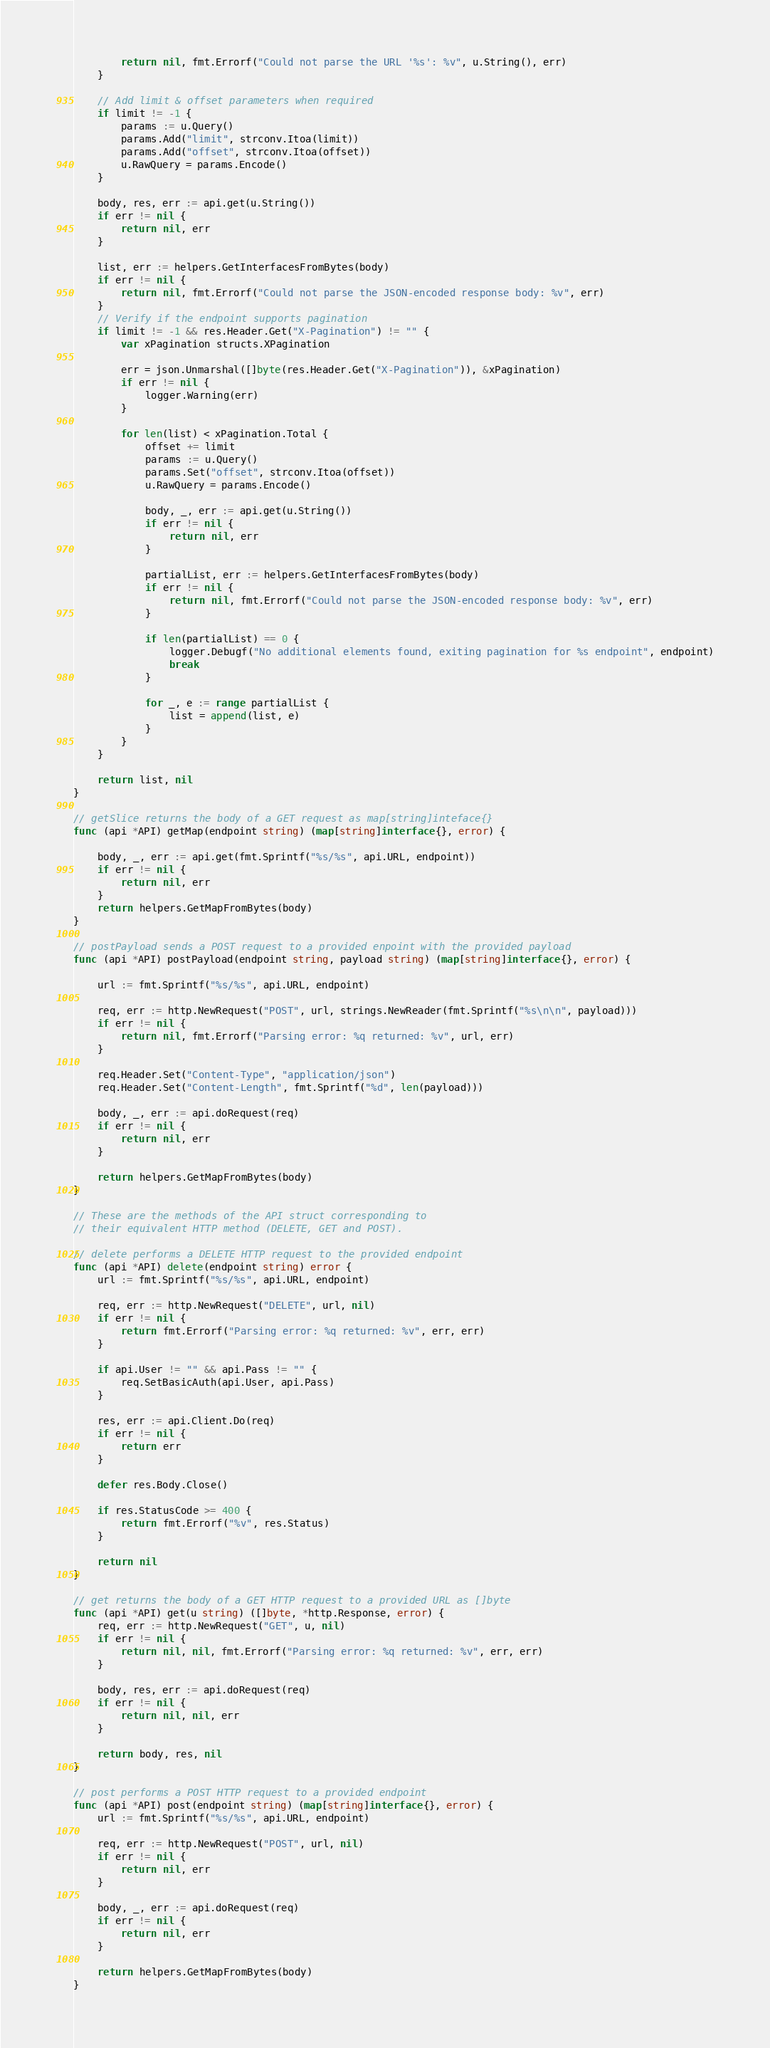Convert code to text. <code><loc_0><loc_0><loc_500><loc_500><_Go_>		return nil, fmt.Errorf("Could not parse the URL '%s': %v", u.String(), err)
	}

	// Add limit & offset parameters when required
	if limit != -1 {
		params := u.Query()
		params.Add("limit", strconv.Itoa(limit))
		params.Add("offset", strconv.Itoa(offset))
		u.RawQuery = params.Encode()
	}

	body, res, err := api.get(u.String())
	if err != nil {
		return nil, err
	}

	list, err := helpers.GetInterfacesFromBytes(body)
	if err != nil {
		return nil, fmt.Errorf("Could not parse the JSON-encoded response body: %v", err)
	}
	// Verify if the endpoint supports pagination
	if limit != -1 && res.Header.Get("X-Pagination") != "" {
		var xPagination structs.XPagination

		err = json.Unmarshal([]byte(res.Header.Get("X-Pagination")), &xPagination)
		if err != nil {
			logger.Warning(err)
		}

		for len(list) < xPagination.Total {
			offset += limit
			params := u.Query()
			params.Set("offset", strconv.Itoa(offset))
			u.RawQuery = params.Encode()

			body, _, err := api.get(u.String())
			if err != nil {
				return nil, err
			}

			partialList, err := helpers.GetInterfacesFromBytes(body)
			if err != nil {
				return nil, fmt.Errorf("Could not parse the JSON-encoded response body: %v", err)
			}

			if len(partialList) == 0 {
				logger.Debugf("No additional elements found, exiting pagination for %s endpoint", endpoint)
				break
			}

			for _, e := range partialList {
				list = append(list, e)
			}
		}
	}

	return list, nil
}

// getSlice returns the body of a GET request as map[string]inteface{}
func (api *API) getMap(endpoint string) (map[string]interface{}, error) {

	body, _, err := api.get(fmt.Sprintf("%s/%s", api.URL, endpoint))
	if err != nil {
		return nil, err
	}
	return helpers.GetMapFromBytes(body)
}

// postPayload sends a POST request to a provided enpoint with the provided payload
func (api *API) postPayload(endpoint string, payload string) (map[string]interface{}, error) {

	url := fmt.Sprintf("%s/%s", api.URL, endpoint)

	req, err := http.NewRequest("POST", url, strings.NewReader(fmt.Sprintf("%s\n\n", payload)))
	if err != nil {
		return nil, fmt.Errorf("Parsing error: %q returned: %v", url, err)
	}

	req.Header.Set("Content-Type", "application/json")
	req.Header.Set("Content-Length", fmt.Sprintf("%d", len(payload)))

	body, _, err := api.doRequest(req)
	if err != nil {
		return nil, err
	}

	return helpers.GetMapFromBytes(body)
}

// These are the methods of the API struct corresponding to
// their equivalent HTTP method (DELETE, GET and POST).

// delete performs a DELETE HTTP request to the provided endpoint
func (api *API) delete(endpoint string) error {
	url := fmt.Sprintf("%s/%s", api.URL, endpoint)

	req, err := http.NewRequest("DELETE", url, nil)
	if err != nil {
		return fmt.Errorf("Parsing error: %q returned: %v", err, err)
	}

	if api.User != "" && api.Pass != "" {
		req.SetBasicAuth(api.User, api.Pass)
	}

	res, err := api.Client.Do(req)
	if err != nil {
		return err
	}

	defer res.Body.Close()

	if res.StatusCode >= 400 {
		return fmt.Errorf("%v", res.Status)
	}

	return nil
}

// get returns the body of a GET HTTP request to a provided URL as []byte
func (api *API) get(u string) ([]byte, *http.Response, error) {
	req, err := http.NewRequest("GET", u, nil)
	if err != nil {
		return nil, nil, fmt.Errorf("Parsing error: %q returned: %v", err, err)
	}

	body, res, err := api.doRequest(req)
	if err != nil {
		return nil, nil, err
	}

	return body, res, nil
}

// post performs a POST HTTP request to a provided endpoint
func (api *API) post(endpoint string) (map[string]interface{}, error) {
	url := fmt.Sprintf("%s/%s", api.URL, endpoint)

	req, err := http.NewRequest("POST", url, nil)
	if err != nil {
		return nil, err
	}

	body, _, err := api.doRequest(req)
	if err != nil {
		return nil, err
	}

	return helpers.GetMapFromBytes(body)
}
</code> 